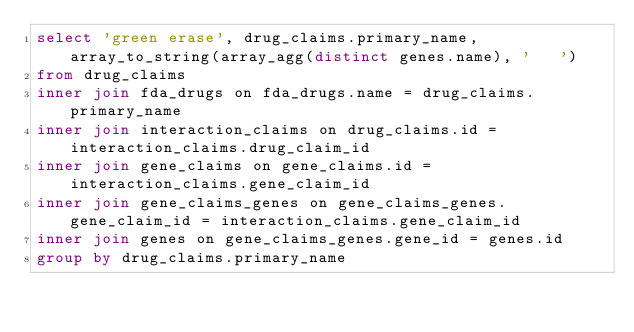Convert code to text. <code><loc_0><loc_0><loc_500><loc_500><_SQL_>select 'green erase', drug_claims.primary_name, array_to_string(array_agg(distinct genes.name), '	')
from drug_claims
inner join fda_drugs on fda_drugs.name = drug_claims.primary_name
inner join interaction_claims on drug_claims.id = interaction_claims.drug_claim_id
inner join gene_claims on gene_claims.id = interaction_claims.gene_claim_id
inner join gene_claims_genes on gene_claims_genes.gene_claim_id = interaction_claims.gene_claim_id
inner join genes on gene_claims_genes.gene_id = genes.id
group by drug_claims.primary_name
</code> 